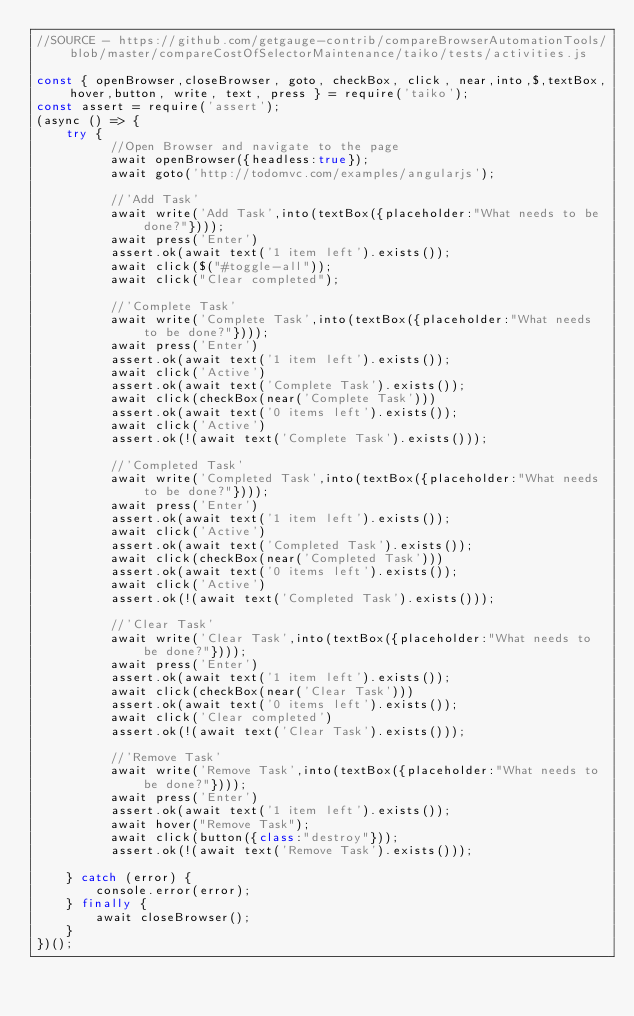<code> <loc_0><loc_0><loc_500><loc_500><_JavaScript_>//SOURCE - https://github.com/getgauge-contrib/compareBrowserAutomationTools/blob/master/compareCostOfSelectorMaintenance/taiko/tests/activities.js

const { openBrowser,closeBrowser, goto, checkBox, click, near,into,$,textBox,hover,button, write, text, press } = require('taiko');
const assert = require('assert');
(async () => {
    try {
          //Open Browser and navigate to the page
          await openBrowser({headless:true});
          await goto('http://todomvc.com/examples/angularjs');

          //'Add Task'
          await write('Add Task',into(textBox({placeholder:"What needs to be done?"})));
          await press('Enter')
          assert.ok(await text('1 item left').exists());
          await click($("#toggle-all"));
          await click("Clear completed");

          //'Complete Task'
          await write('Complete Task',into(textBox({placeholder:"What needs to be done?"})));
          await press('Enter')
          assert.ok(await text('1 item left').exists());
          await click('Active')
          assert.ok(await text('Complete Task').exists());
          await click(checkBox(near('Complete Task')))
          assert.ok(await text('0 items left').exists());
          await click('Active')
          assert.ok(!(await text('Complete Task').exists()));

          //'Completed Task'
          await write('Completed Task',into(textBox({placeholder:"What needs to be done?"})));
          await press('Enter')
          assert.ok(await text('1 item left').exists());
          await click('Active')
          assert.ok(await text('Completed Task').exists());
          await click(checkBox(near('Completed Task')))
          assert.ok(await text('0 items left').exists());
          await click('Active')
          assert.ok(!(await text('Completed Task').exists()));

          //'Clear Task'
          await write('Clear Task',into(textBox({placeholder:"What needs to be done?"})));
          await press('Enter')
          assert.ok(await text('1 item left').exists());
          await click(checkBox(near('Clear Task')))
          assert.ok(await text('0 items left').exists());
          await click('Clear completed')
          assert.ok(!(await text('Clear Task').exists()));

          //'Remove Task'
          await write('Remove Task',into(textBox({placeholder:"What needs to be done?"})));
          await press('Enter')
          assert.ok(await text('1 item left').exists());
          await hover("Remove Task");
          await click(button({class:"destroy"}));
          assert.ok(!(await text('Remove Task').exists()));

    } catch (error) {
        console.error(error);
    } finally {
        await closeBrowser();
    }
})();</code> 